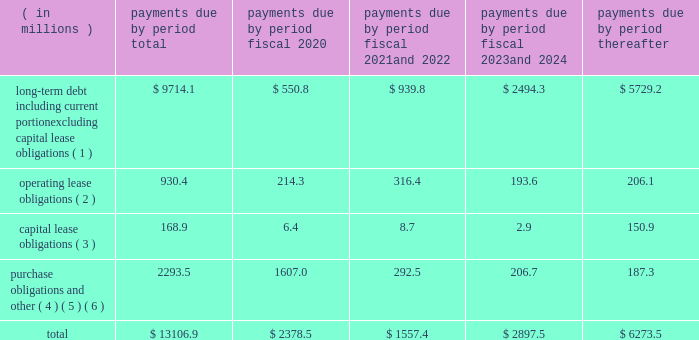Factors , including the market price of our common stock , general economic and market conditions and applicable legal requirements .
The repurchase program may be commenced , suspended or discontinued at any time .
In fiscal 2019 , we repurchased approximately 2.1 million shares of our common stock for an aggregate cost of $ 88.6 million .
In fiscal 2018 , we repurchased approximately 3.4 million shares of our common stock for an aggregate cost of $ 195.1 million .
As of september 30 , 2019 , we had approximately 19.1 million shares of common stock available for repurchase under the program .
We anticipate that we will be able to fund our capital expenditures , interest payments , dividends and stock repurchases , pension payments , working capital needs , note repurchases , restructuring activities , repayments of current portion of long-term debt and other corporate actions for the foreseeable future from cash generated from operations , borrowings under our credit facilities , proceeds from our a/r sales agreement , proceeds from the issuance of debt or equity securities or other additional long-term debt financing , including new or amended facilities .
In addition , we continually review our capital structure and conditions in the private and public debt markets in order to optimize our mix of indebtedness .
In connection with these reviews , we may seek to refinance existing indebtedness to extend maturities , reduce borrowing costs or otherwise improve the terms and composition of our indebtedness .
Contractual obligations we summarize our enforceable and legally binding contractual obligations at september 30 , 2019 , and the effect these obligations are expected to have on our liquidity and cash flow in future periods in the table .
Certain amounts in this table are based on management 2019s estimates and assumptions about these obligations , including their duration , the possibility of renewal , anticipated actions by third parties and other factors , including estimated minimum pension plan contributions and estimated benefit payments related to postretirement obligations , supplemental retirement plans and deferred compensation plans .
Because these estimates and assumptions are subjective , the enforceable and legally binding obligations we actually pay in future periods may vary from those presented in the table. .
( 1 ) includes only principal payments owed on our debt assuming that all of our long-term debt will be held to maturity , excluding scheduled payments .
We have excluded $ 163.5 million of fair value of debt step-up , deferred financing costs and unamortized bond discounts from the table to arrive at actual debt obligations .
See 201cnote 13 .
Debt 201d of the notes to consolidated financial statements for information on the interest rates that apply to our various debt instruments .
( 2 ) see 201cnote 15 .
Operating leases 201d of the notes to consolidated financial statements for additional information .
( 3 ) the fair value step-up of $ 16.9 million is excluded .
See 201cnote 13 .
Debt 2014 capital lease and other indebtedness 201d of the notes to consolidated financial statements for additional information .
( 4 ) purchase obligations include agreements to purchase goods or services that are enforceable and legally binding and that specify all significant terms , including : fixed or minimum quantities to be purchased ; fixed , minimum or variable price provision ; and the approximate timing of the transaction .
Purchase obligations exclude agreements that are cancelable without penalty .
( 5 ) we have included in the table future estimated minimum pension plan contributions and estimated benefit payments related to postretirement obligations , supplemental retirement plans and deferred compensation plans .
Our estimates are based on factors , such as discount rates and expected returns on plan assets .
Future contributions are subject to changes in our underfunded status based on factors such as investment performance , discount rates , returns on plan assets and changes in legislation .
It is possible that our assumptions may change , actual market performance may vary or we may decide to contribute different amounts .
We have excluded $ 237.2 million of multiemployer pension plan withdrawal liabilities recorded as of september 30 , 2019 , including our estimate of the accumulated funding deficiency , due to lack of .
What was the average of the operating lease obligations between 2020 and 2024? 
Computations: ((930.4 - 206.1) / 5)
Answer: 144.86. 